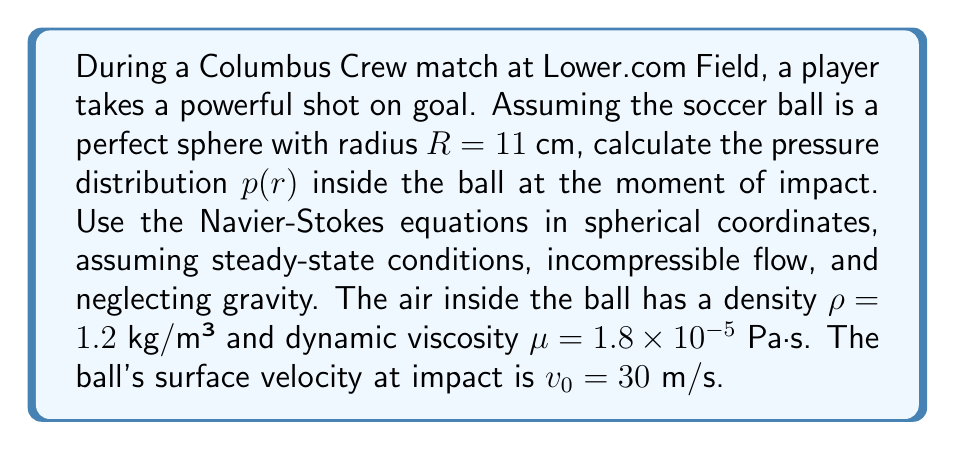Teach me how to tackle this problem. To solve this problem, we'll use the Navier-Stokes equations in spherical coordinates, assuming steady-state conditions and incompressible flow. We'll also neglect gravity due to the small scale of the problem.

1. The Navier-Stokes equation for radial flow in spherical coordinates, assuming azimuthal symmetry, is:

   $$\rho \left(v_r \frac{\partial v_r}{\partial r} + \frac{v_\theta}{r} \frac{\partial v_r}{\partial \theta} - \frac{v_\theta^2 + v_\phi^2}{r}\right) = -\frac{\partial p}{\partial r} + \mu \left[\frac{1}{r^2}\frac{\partial}{\partial r}\left(r^2\frac{\partial v_r}{\partial r}\right) + \frac{1}{r^2\sin\theta}\frac{\partial}{\partial \theta}\left(\sin\theta\frac{\partial v_r}{\partial \theta}\right) - \frac{2v_r}{r^2} - \frac{2}{r^2}\frac{\partial v_\theta}{\partial \theta}\right]$$

2. Given the symmetry of the problem, we can assume that the flow is purely radial and independent of $\theta$ and $\phi$. This simplifies our equation to:

   $$\rho v_r \frac{\partial v_r}{\partial r} = -\frac{\partial p}{\partial r} + \mu \left[\frac{1}{r^2}\frac{\partial}{\partial r}\left(r^2\frac{\partial v_r}{\partial r}\right) - \frac{2v_r}{r^2}\right]$$

3. For incompressible flow, the continuity equation in spherical coordinates reduces to:

   $$\frac{1}{r^2}\frac{\partial}{\partial r}(r^2v_r) = 0$$

4. Solving the continuity equation, we get:

   $$v_r = \frac{C}{r^2}$$

   where $C$ is a constant determined by the boundary condition $v_r(R) = -v_0$.

5. Substituting this into our simplified Navier-Stokes equation:

   $$-\rho \frac{2C^2}{r^5} = -\frac{\partial p}{\partial r} + \mu \left[-\frac{6C}{r^5}\right]$$

6. Rearranging and integrating with respect to $r$:

   $$p(r) = \frac{2\rho C^2}{4r^4} + \frac{6\mu C}{r^3} + K$$

   where $K$ is an integration constant.

7. To determine $C$ and $K$, we use the boundary conditions:
   - At $r = R$, $v_r = -v_0$, so $C = -v_0R^2$
   - At $r = R$, $p = p_0$ (atmospheric pressure)

8. Substituting these conditions:

   $$p(r) = p_0 + \frac{2\rho v_0^2R^4}{4r^4} - \frac{6\mu v_0R^2}{r^3} - \frac{2\rho v_0^2R^4}{4R^4} + \frac{6\mu v_0R^2}{R^3}$$

9. Simplifying:

   $$p(r) = p_0 + \frac{\rho v_0^2R^4}{2}\left(\frac{1}{r^4} - \frac{1}{R^4}\right) - 6\mu v_0R^2\left(\frac{1}{r^3} - \frac{1}{R^3}\right)$$

This equation gives the pressure distribution inside the soccer ball as a function of radial distance $r$ from the center.
Answer: $$p(r) = p_0 + \frac{\rho v_0^2R^4}{2}\left(\frac{1}{r^4} - \frac{1}{R^4}\right) - 6\mu v_0R^2\left(\frac{1}{r^3} - \frac{1}{R^3}\right)$$

where $p_0$ is the atmospheric pressure, $\rho = 1.2$ kg/m³, $v_0 = 30$ m/s, $R = 0.11$ m, and $\mu = 1.8 \times 10^{-5}$ Pa·s. 